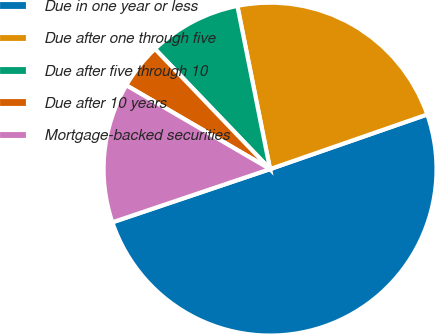Convert chart. <chart><loc_0><loc_0><loc_500><loc_500><pie_chart><fcel>Due in one year or less<fcel>Due after one through five<fcel>Due after five through 10<fcel>Due after 10 years<fcel>Mortgage-backed securities<nl><fcel>50.14%<fcel>22.82%<fcel>9.01%<fcel>4.44%<fcel>13.58%<nl></chart> 